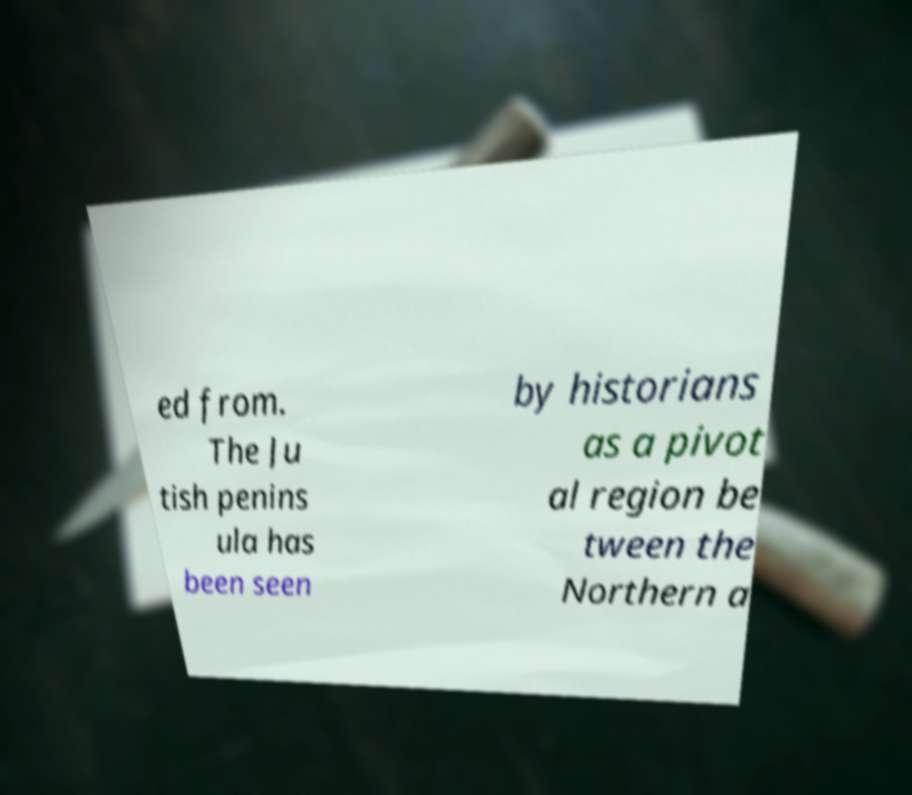For documentation purposes, I need the text within this image transcribed. Could you provide that? ed from. The Ju tish penins ula has been seen by historians as a pivot al region be tween the Northern a 